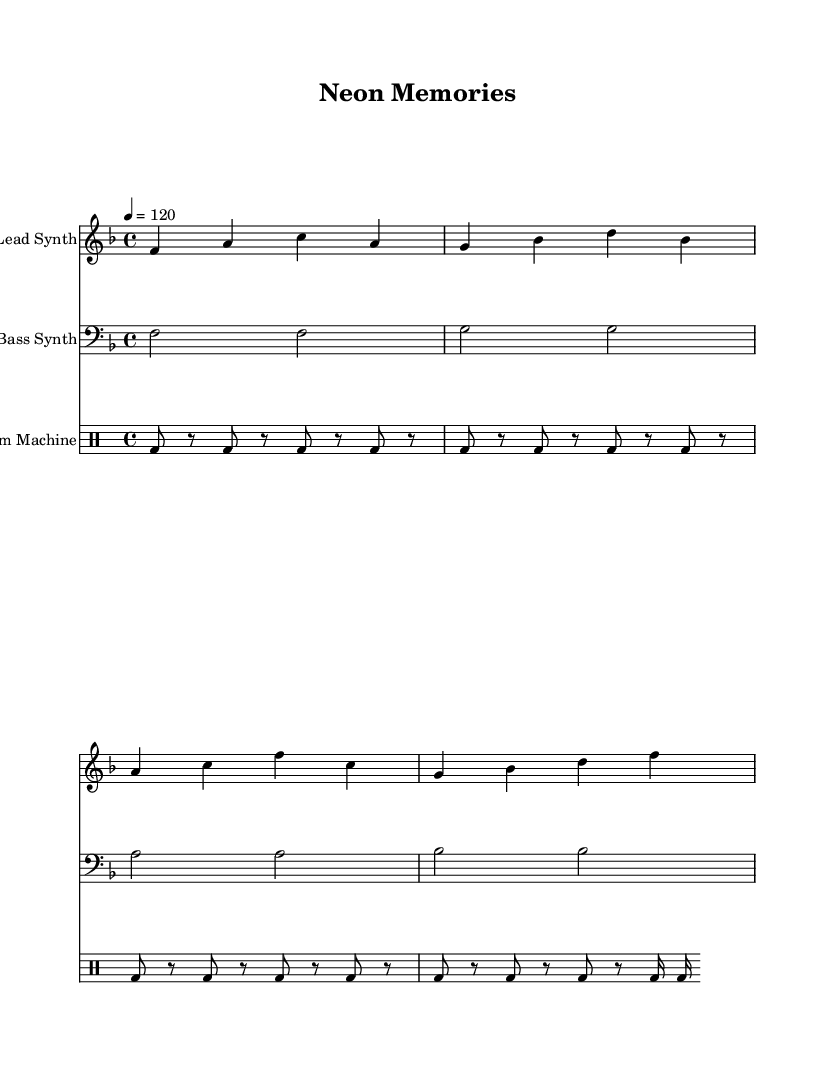What is the key signature of this music? The key signature is indicated at the beginning of the staff with the symbol for F major, which has one flat (B♭).
Answer: F major What is the time signature of this music? The time signature is found at the beginning of the score, represented by the fraction that shows four beats in each measure, indicated as 4/4.
Answer: 4/4 What is the tempo marking of this piece? The tempo is specified above the staff as "4 = 120," indicating that the quarter note equals 120 beats per minute.
Answer: 120 How many measures are in the lead synth part? By counting the distinct groups of four beats with vertical lines (bar lines) present in the lead synth part, we can identify the total measures, which is four in this case.
Answer: 4 What is the total number of different notes in the bass synth part? The bass synth part consists of the notes F, G, A, and B♭, and by counting them up, we see there are four distinct notes.
Answer: 4 Which rhythmic figure is used in the drum machine part? The rhythmic figure is identified by the sequence of bass drum hits represented; in this case, it is a repeated pattern of eighth notes followed by the use of rests.
Answer: Eighth notes What type of synthesizer is represented in the first staff? The first staff is labeled "Lead Synth," which indicates it is meant to represent a melodic synthesizer commonly used in electronic music for leads.
Answer: Lead Synth 